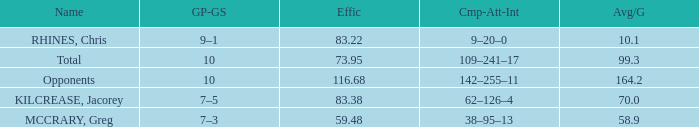What is the total avg/g of McCrary, Greg? 1.0. 